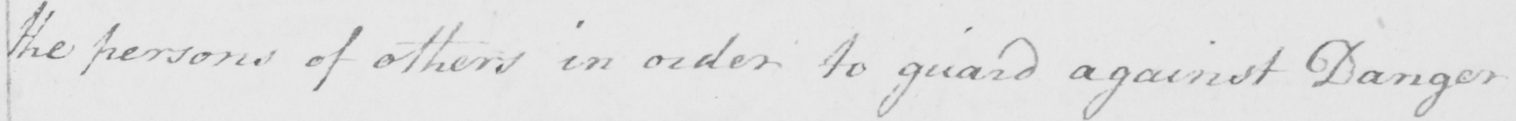Can you read and transcribe this handwriting? the persons of others in order to guard against Danger 